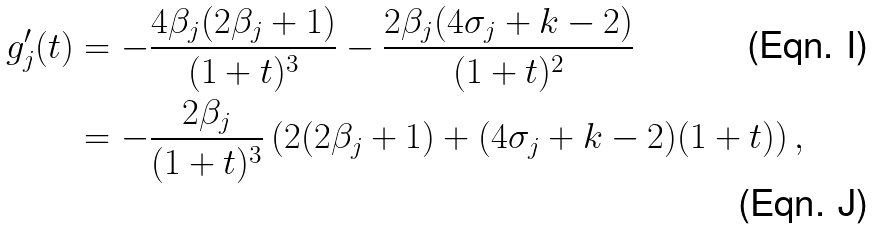Convert formula to latex. <formula><loc_0><loc_0><loc_500><loc_500>g _ { j } ^ { \prime } ( t ) & = - \frac { 4 \beta _ { j } ( 2 \beta _ { j } + 1 ) } { ( 1 + t ) ^ { 3 } } - \frac { 2 \beta _ { j } ( 4 \sigma _ { j } + k - 2 ) } { ( 1 + t ) ^ { 2 } } \\ & = - \frac { 2 \beta _ { j } } { ( 1 + t ) ^ { 3 } } \left ( 2 ( 2 \beta _ { j } + 1 ) + ( 4 \sigma _ { j } + k - 2 ) ( 1 + t ) \right ) ,</formula> 